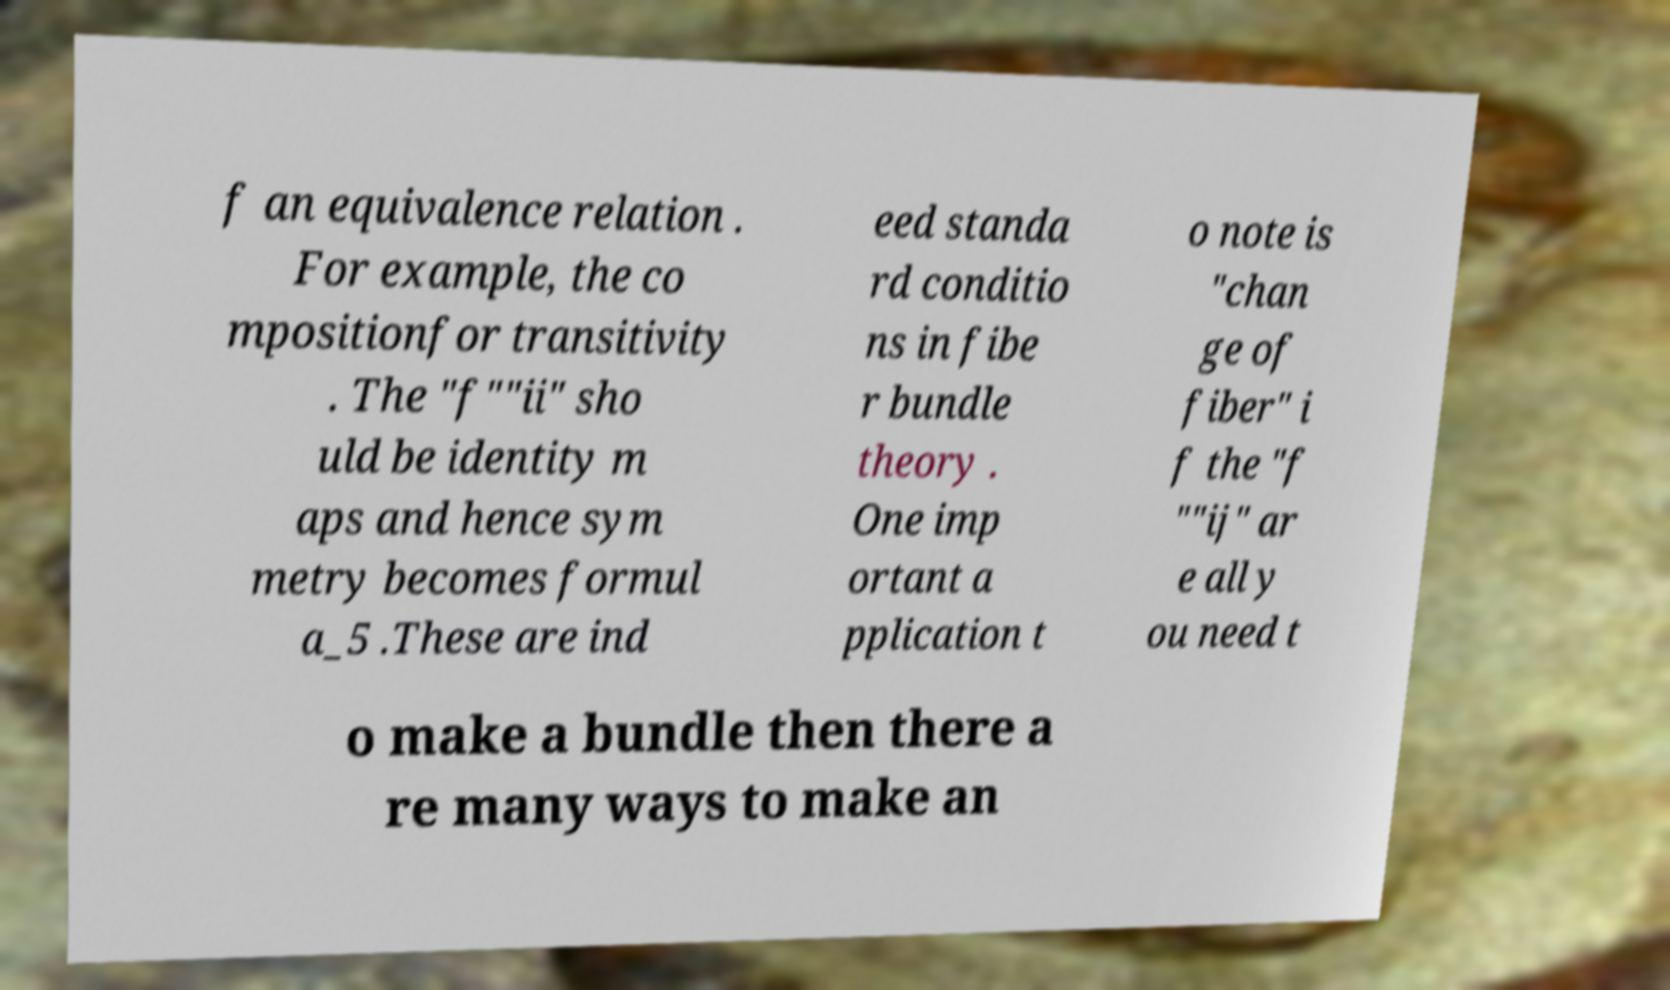Can you read and provide the text displayed in the image?This photo seems to have some interesting text. Can you extract and type it out for me? f an equivalence relation . For example, the co mpositionfor transitivity . The "f""ii" sho uld be identity m aps and hence sym metry becomes formul a_5 .These are ind eed standa rd conditio ns in fibe r bundle theory . One imp ortant a pplication t o note is "chan ge of fiber" i f the "f ""ij" ar e all y ou need t o make a bundle then there a re many ways to make an 